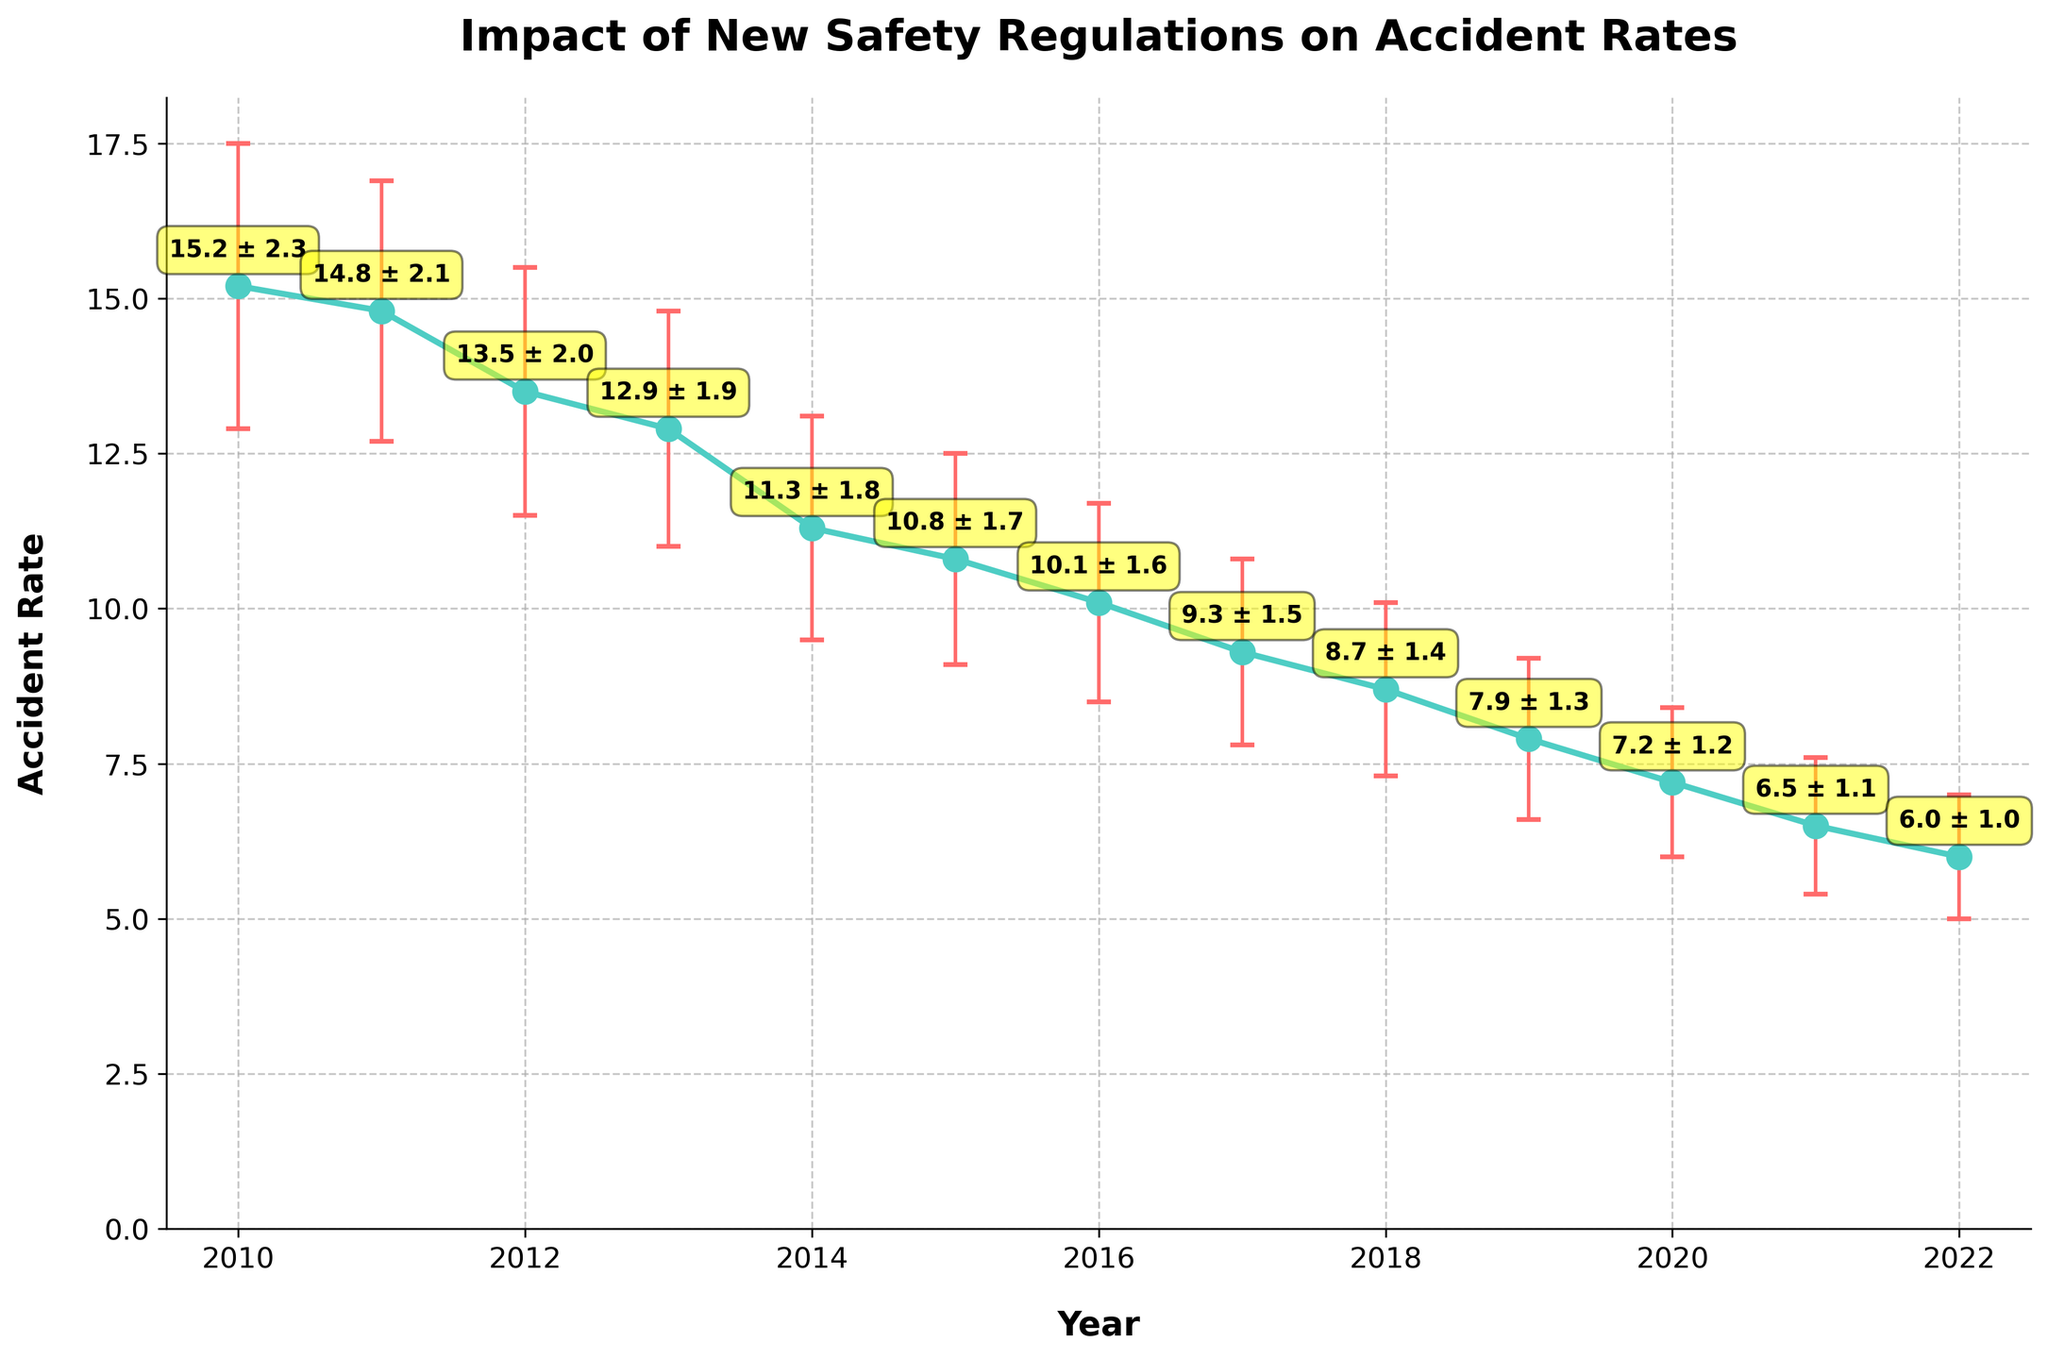How many years are depicted in the plot? The x-axis of the plot shows the years from 2010 to 2022. Counting from 2010 to 2022 inclusively, there are 13 data points.
Answer: 13 What is the accident rate in the year 2016? The y-axis is labeled "Accident Rate" and the data point for 2016 shows an accident rate of 10.1 with a standard deviation of 1.6.
Answer: 10.1 In which year did the accident rate first fall below 10? Observing the line plot and error bars, the accident rate first drops below 10 in 2017.
Answer: 2017 How does the accident rate in 2010 compare to the accident rate in 2022? The accident rate in 2010 is 15.2, and in 2022 it is 6.0. The rate in 2010 is significantly higher than in 2022.
Answer: 15.2 in 2010, 6.0 in 2022 What is the trend of the accident rates over the years? The accident rate consistently decreases from 2010 to 2022.
Answer: Decreasing trend Calculate the average accident rate from 2010 to 2012. Sum the accident rates for 2010, 2011, and 2012, then divide by 3: (15.2 + 14.8 + 13.5)/3 = 14.5.
Answer: 14.5 Which year shows the lowest accident rate, and what is that rate? By looking at the plot, 2022 has the lowest accident rate, which is 6.0.
Answer: 2022, 6.0 What is the error range for the accident rate in 2019? The accident rate in 2019 is 7.9 with a standard deviation of 1.3, so the range is: 7.9 ± 1.3 (6.6 to 9.2).
Answer: 6.6 to 9.2 What pattern can you observe from the error bars? The lengths of the error bars decrease over the years, indicating a reduction in standard deviation.
Answer: Decreasing length Are there any significant outliers or irregularities in the trend observed? There are no significant outliers; all data points show a consistent downward trend in accident rates.
Answer: No significant outliers 